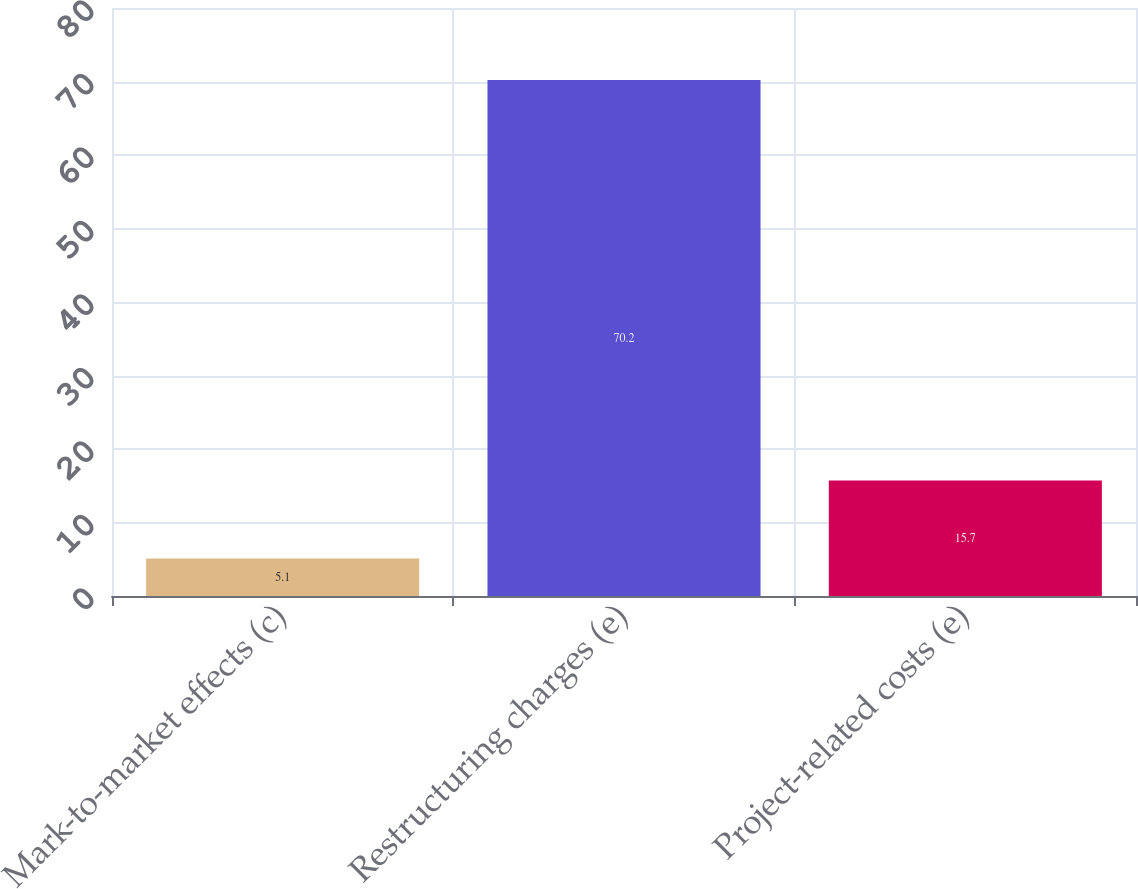Convert chart to OTSL. <chart><loc_0><loc_0><loc_500><loc_500><bar_chart><fcel>Mark-to-market effects (c)<fcel>Restructuring charges (e)<fcel>Project-related costs (e)<nl><fcel>5.1<fcel>70.2<fcel>15.7<nl></chart> 